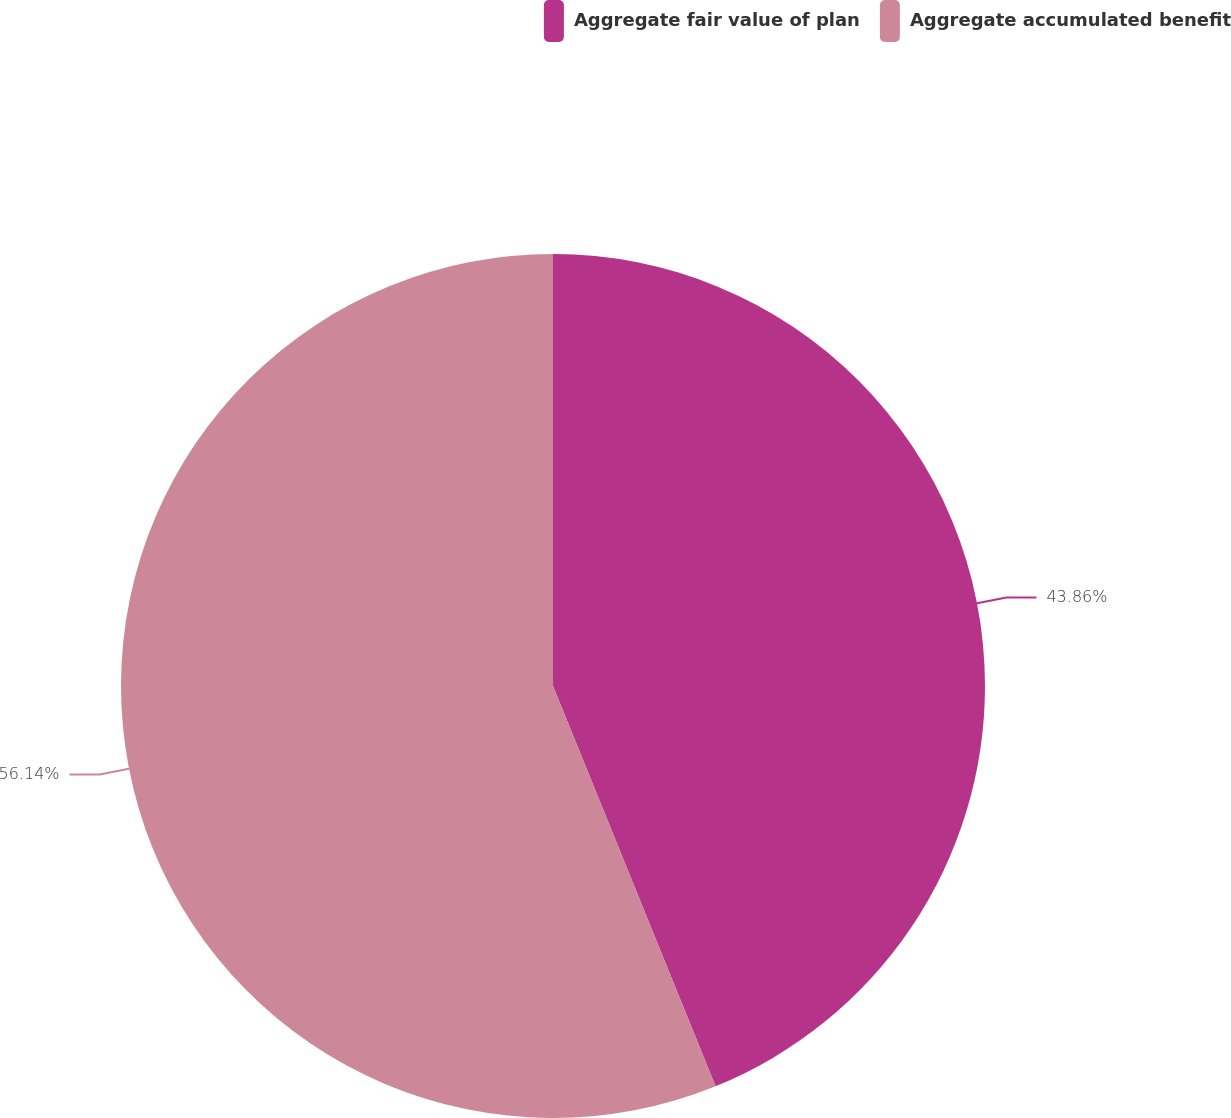Convert chart. <chart><loc_0><loc_0><loc_500><loc_500><pie_chart><fcel>Aggregate fair value of plan<fcel>Aggregate accumulated benefit<nl><fcel>43.86%<fcel>56.14%<nl></chart> 